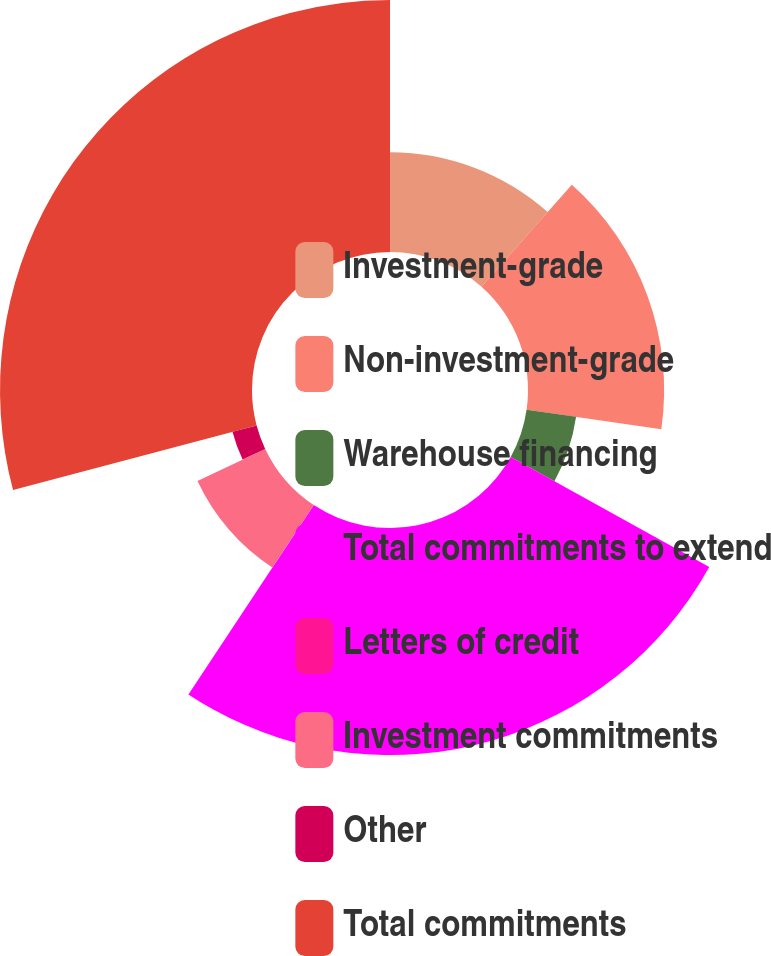<chart> <loc_0><loc_0><loc_500><loc_500><pie_chart><fcel>Investment-grade<fcel>Non-investment-grade<fcel>Warehouse financing<fcel>Total commitments to extend<fcel>Letters of credit<fcel>Investment commitments<fcel>Other<fcel>Total commitments<nl><fcel>11.54%<fcel>15.74%<fcel>5.78%<fcel>26.25%<fcel>0.01%<fcel>8.66%<fcel>2.89%<fcel>29.13%<nl></chart> 